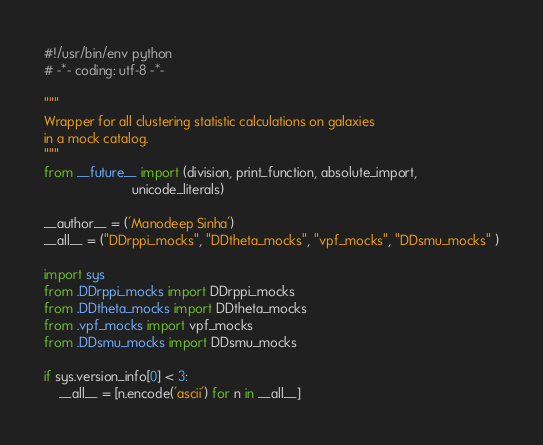<code> <loc_0><loc_0><loc_500><loc_500><_Python_>#!/usr/bin/env python
# -*- coding: utf-8 -*-

"""
Wrapper for all clustering statistic calculations on galaxies
in a mock catalog.
"""
from __future__ import (division, print_function, absolute_import,
                        unicode_literals)

__author__ = ('Manodeep Sinha')
__all__ = ("DDrppi_mocks", "DDtheta_mocks", "vpf_mocks", "DDsmu_mocks" )

import sys
from .DDrppi_mocks import DDrppi_mocks
from .DDtheta_mocks import DDtheta_mocks
from .vpf_mocks import vpf_mocks
from .DDsmu_mocks import DDsmu_mocks

if sys.version_info[0] < 3:
    __all__ = [n.encode('ascii') for n in __all__]
</code> 